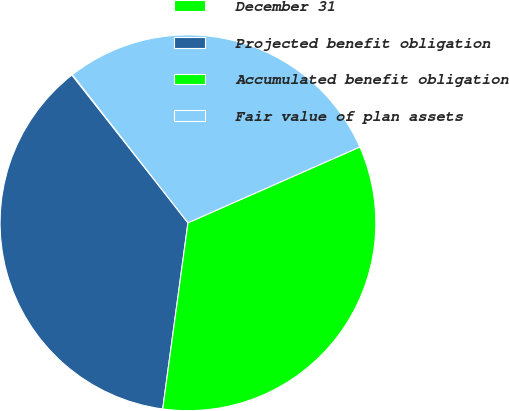Convert chart. <chart><loc_0><loc_0><loc_500><loc_500><pie_chart><fcel>December 31<fcel>Projected benefit obligation<fcel>Accumulated benefit obligation<fcel>Fair value of plan assets<nl><fcel>0.06%<fcel>37.25%<fcel>33.76%<fcel>28.93%<nl></chart> 